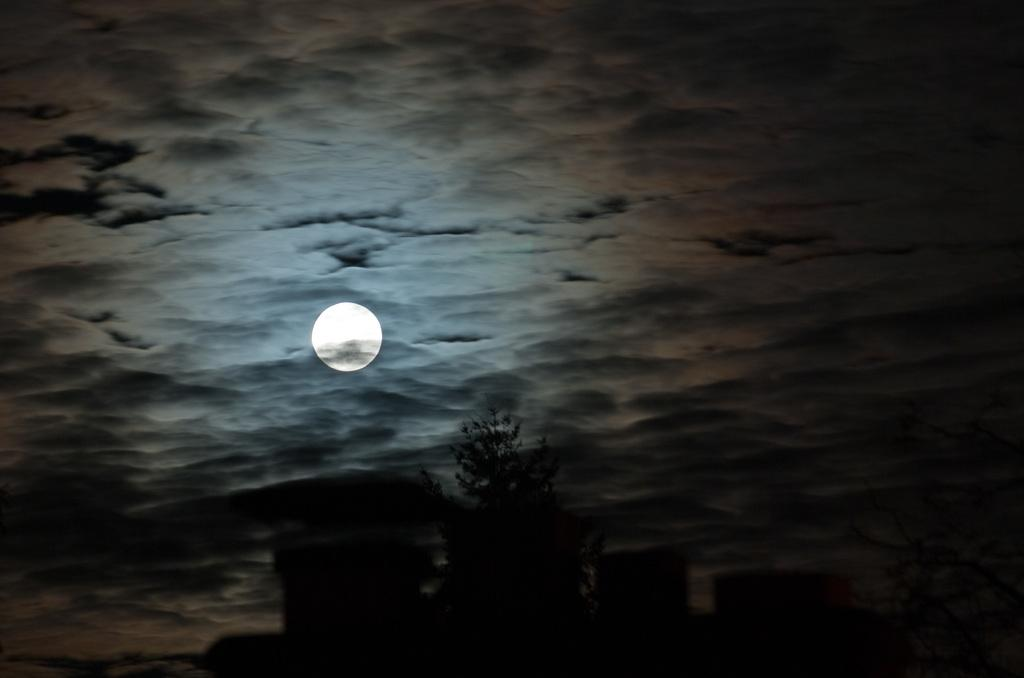What type of natural element can be seen in the image? There is a tree in the image. What can be observed on the ground in the image? There are shadows of objects in the image. What celestial body is visible in the background of the image? The moon is visible in the background of the image. What is the color of the moon in the image? The moon is white in color. What else can be seen in the background of the image? The sky is visible in the background of the image. How many bottles are present in the image? There are no bottles present in the image. 